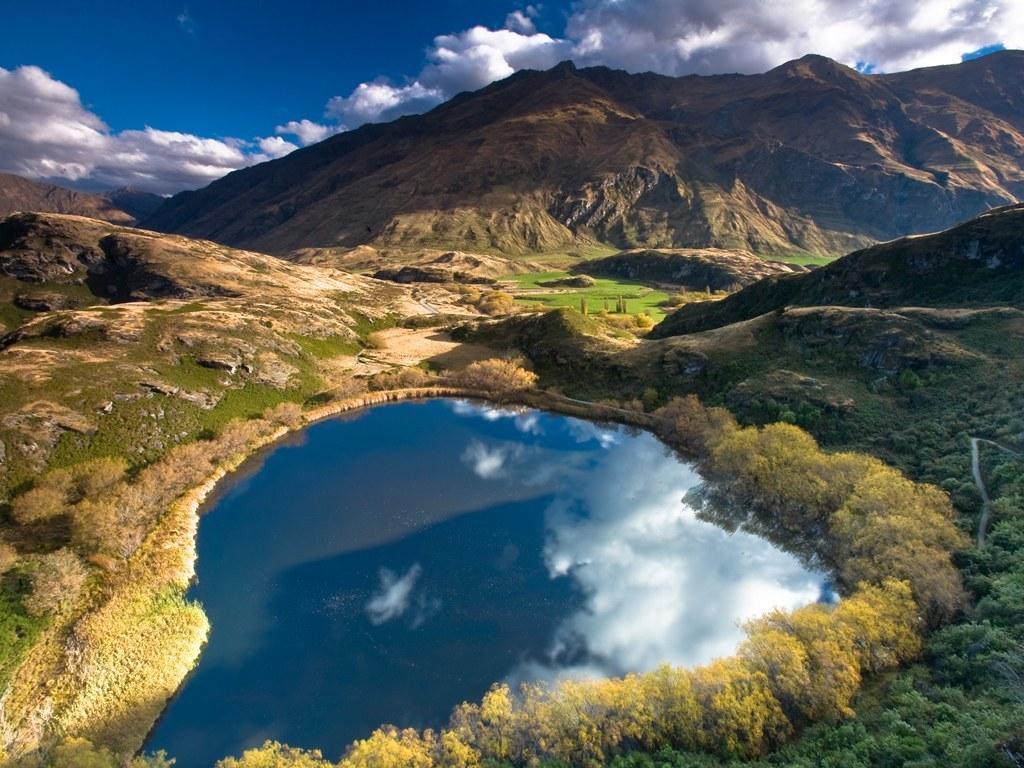Could you give a brief overview of what you see in this image? Sky is cloudy. Here we can see plants and grass. On this water there is a reflection of clouds. 